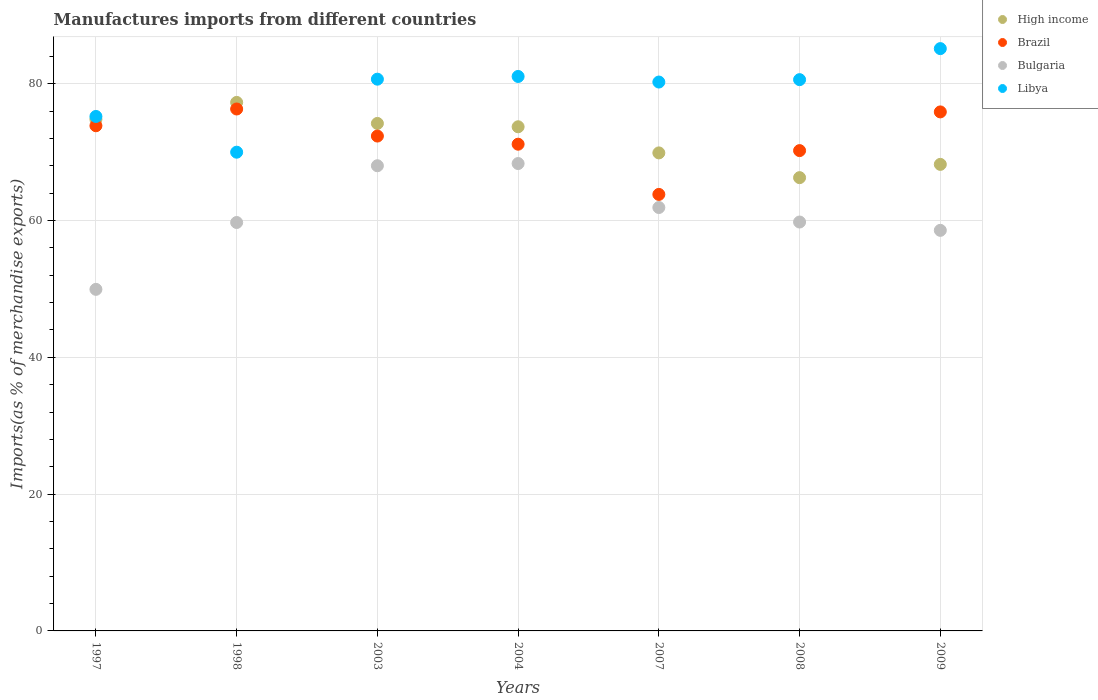Is the number of dotlines equal to the number of legend labels?
Offer a very short reply. Yes. What is the percentage of imports to different countries in Libya in 2004?
Give a very brief answer. 81.06. Across all years, what is the maximum percentage of imports to different countries in Libya?
Offer a terse response. 85.13. Across all years, what is the minimum percentage of imports to different countries in Libya?
Your answer should be compact. 69.99. What is the total percentage of imports to different countries in High income in the graph?
Your answer should be very brief. 504.31. What is the difference between the percentage of imports to different countries in Libya in 2004 and that in 2007?
Your response must be concise. 0.82. What is the difference between the percentage of imports to different countries in Brazil in 2003 and the percentage of imports to different countries in Bulgaria in 2008?
Offer a terse response. 12.57. What is the average percentage of imports to different countries in Libya per year?
Provide a succinct answer. 78.98. In the year 2004, what is the difference between the percentage of imports to different countries in Bulgaria and percentage of imports to different countries in Brazil?
Offer a terse response. -2.83. What is the ratio of the percentage of imports to different countries in Brazil in 1997 to that in 2007?
Ensure brevity in your answer.  1.16. What is the difference between the highest and the second highest percentage of imports to different countries in Libya?
Your response must be concise. 4.07. What is the difference between the highest and the lowest percentage of imports to different countries in Brazil?
Offer a terse response. 12.49. Is the sum of the percentage of imports to different countries in Bulgaria in 2003 and 2004 greater than the maximum percentage of imports to different countries in Brazil across all years?
Provide a succinct answer. Yes. Does the percentage of imports to different countries in Brazil monotonically increase over the years?
Your answer should be very brief. No. Is the percentage of imports to different countries in Bulgaria strictly greater than the percentage of imports to different countries in High income over the years?
Provide a succinct answer. No. How many dotlines are there?
Give a very brief answer. 4. What is the difference between two consecutive major ticks on the Y-axis?
Give a very brief answer. 20. Does the graph contain any zero values?
Ensure brevity in your answer.  No. Does the graph contain grids?
Offer a very short reply. Yes. What is the title of the graph?
Keep it short and to the point. Manufactures imports from different countries. Does "Pacific island small states" appear as one of the legend labels in the graph?
Your response must be concise. No. What is the label or title of the X-axis?
Give a very brief answer. Years. What is the label or title of the Y-axis?
Ensure brevity in your answer.  Imports(as % of merchandise exports). What is the Imports(as % of merchandise exports) of High income in 1997?
Your response must be concise. 74.79. What is the Imports(as % of merchandise exports) in Brazil in 1997?
Your response must be concise. 73.85. What is the Imports(as % of merchandise exports) of Bulgaria in 1997?
Offer a very short reply. 49.93. What is the Imports(as % of merchandise exports) of Libya in 1997?
Offer a terse response. 75.21. What is the Imports(as % of merchandise exports) of High income in 1998?
Your answer should be compact. 77.27. What is the Imports(as % of merchandise exports) in Brazil in 1998?
Make the answer very short. 76.3. What is the Imports(as % of merchandise exports) in Bulgaria in 1998?
Provide a short and direct response. 59.71. What is the Imports(as % of merchandise exports) in Libya in 1998?
Your answer should be compact. 69.99. What is the Imports(as % of merchandise exports) of High income in 2003?
Ensure brevity in your answer.  74.19. What is the Imports(as % of merchandise exports) of Brazil in 2003?
Your answer should be compact. 72.35. What is the Imports(as % of merchandise exports) in Bulgaria in 2003?
Give a very brief answer. 68.01. What is the Imports(as % of merchandise exports) in Libya in 2003?
Give a very brief answer. 80.66. What is the Imports(as % of merchandise exports) in High income in 2004?
Provide a succinct answer. 73.7. What is the Imports(as % of merchandise exports) in Brazil in 2004?
Provide a short and direct response. 71.16. What is the Imports(as % of merchandise exports) in Bulgaria in 2004?
Keep it short and to the point. 68.33. What is the Imports(as % of merchandise exports) in Libya in 2004?
Make the answer very short. 81.06. What is the Imports(as % of merchandise exports) in High income in 2007?
Give a very brief answer. 69.88. What is the Imports(as % of merchandise exports) of Brazil in 2007?
Your answer should be compact. 63.82. What is the Imports(as % of merchandise exports) in Bulgaria in 2007?
Offer a very short reply. 61.9. What is the Imports(as % of merchandise exports) of Libya in 2007?
Your answer should be very brief. 80.24. What is the Imports(as % of merchandise exports) in High income in 2008?
Provide a short and direct response. 66.27. What is the Imports(as % of merchandise exports) of Brazil in 2008?
Your answer should be very brief. 70.22. What is the Imports(as % of merchandise exports) of Bulgaria in 2008?
Provide a succinct answer. 59.78. What is the Imports(as % of merchandise exports) of Libya in 2008?
Your response must be concise. 80.59. What is the Imports(as % of merchandise exports) in High income in 2009?
Keep it short and to the point. 68.21. What is the Imports(as % of merchandise exports) of Brazil in 2009?
Give a very brief answer. 75.88. What is the Imports(as % of merchandise exports) of Bulgaria in 2009?
Provide a succinct answer. 58.56. What is the Imports(as % of merchandise exports) of Libya in 2009?
Ensure brevity in your answer.  85.13. Across all years, what is the maximum Imports(as % of merchandise exports) in High income?
Keep it short and to the point. 77.27. Across all years, what is the maximum Imports(as % of merchandise exports) in Brazil?
Provide a short and direct response. 76.3. Across all years, what is the maximum Imports(as % of merchandise exports) in Bulgaria?
Provide a succinct answer. 68.33. Across all years, what is the maximum Imports(as % of merchandise exports) in Libya?
Make the answer very short. 85.13. Across all years, what is the minimum Imports(as % of merchandise exports) of High income?
Your answer should be very brief. 66.27. Across all years, what is the minimum Imports(as % of merchandise exports) of Brazil?
Offer a very short reply. 63.82. Across all years, what is the minimum Imports(as % of merchandise exports) in Bulgaria?
Give a very brief answer. 49.93. Across all years, what is the minimum Imports(as % of merchandise exports) of Libya?
Make the answer very short. 69.99. What is the total Imports(as % of merchandise exports) in High income in the graph?
Offer a terse response. 504.31. What is the total Imports(as % of merchandise exports) in Brazil in the graph?
Offer a terse response. 503.57. What is the total Imports(as % of merchandise exports) in Bulgaria in the graph?
Make the answer very short. 426.22. What is the total Imports(as % of merchandise exports) of Libya in the graph?
Provide a succinct answer. 552.89. What is the difference between the Imports(as % of merchandise exports) of High income in 1997 and that in 1998?
Make the answer very short. -2.48. What is the difference between the Imports(as % of merchandise exports) of Brazil in 1997 and that in 1998?
Keep it short and to the point. -2.45. What is the difference between the Imports(as % of merchandise exports) in Bulgaria in 1997 and that in 1998?
Provide a short and direct response. -9.77. What is the difference between the Imports(as % of merchandise exports) of Libya in 1997 and that in 1998?
Your response must be concise. 5.23. What is the difference between the Imports(as % of merchandise exports) of High income in 1997 and that in 2003?
Provide a short and direct response. 0.6. What is the difference between the Imports(as % of merchandise exports) of Brazil in 1997 and that in 2003?
Provide a succinct answer. 1.51. What is the difference between the Imports(as % of merchandise exports) of Bulgaria in 1997 and that in 2003?
Keep it short and to the point. -18.07. What is the difference between the Imports(as % of merchandise exports) of Libya in 1997 and that in 2003?
Provide a succinct answer. -5.45. What is the difference between the Imports(as % of merchandise exports) of High income in 1997 and that in 2004?
Make the answer very short. 1.08. What is the difference between the Imports(as % of merchandise exports) of Brazil in 1997 and that in 2004?
Make the answer very short. 2.7. What is the difference between the Imports(as % of merchandise exports) in Bulgaria in 1997 and that in 2004?
Keep it short and to the point. -18.39. What is the difference between the Imports(as % of merchandise exports) of Libya in 1997 and that in 2004?
Your answer should be very brief. -5.85. What is the difference between the Imports(as % of merchandise exports) in High income in 1997 and that in 2007?
Ensure brevity in your answer.  4.9. What is the difference between the Imports(as % of merchandise exports) in Brazil in 1997 and that in 2007?
Your answer should be very brief. 10.04. What is the difference between the Imports(as % of merchandise exports) in Bulgaria in 1997 and that in 2007?
Make the answer very short. -11.97. What is the difference between the Imports(as % of merchandise exports) in Libya in 1997 and that in 2007?
Your answer should be compact. -5.03. What is the difference between the Imports(as % of merchandise exports) in High income in 1997 and that in 2008?
Provide a succinct answer. 8.52. What is the difference between the Imports(as % of merchandise exports) of Brazil in 1997 and that in 2008?
Provide a succinct answer. 3.63. What is the difference between the Imports(as % of merchandise exports) in Bulgaria in 1997 and that in 2008?
Ensure brevity in your answer.  -9.84. What is the difference between the Imports(as % of merchandise exports) of Libya in 1997 and that in 2008?
Your response must be concise. -5.38. What is the difference between the Imports(as % of merchandise exports) of High income in 1997 and that in 2009?
Offer a terse response. 6.58. What is the difference between the Imports(as % of merchandise exports) of Brazil in 1997 and that in 2009?
Provide a succinct answer. -2.02. What is the difference between the Imports(as % of merchandise exports) in Bulgaria in 1997 and that in 2009?
Give a very brief answer. -8.63. What is the difference between the Imports(as % of merchandise exports) of Libya in 1997 and that in 2009?
Offer a terse response. -9.92. What is the difference between the Imports(as % of merchandise exports) in High income in 1998 and that in 2003?
Offer a terse response. 3.07. What is the difference between the Imports(as % of merchandise exports) of Brazil in 1998 and that in 2003?
Offer a very short reply. 3.96. What is the difference between the Imports(as % of merchandise exports) in Bulgaria in 1998 and that in 2003?
Offer a terse response. -8.3. What is the difference between the Imports(as % of merchandise exports) in Libya in 1998 and that in 2003?
Ensure brevity in your answer.  -10.68. What is the difference between the Imports(as % of merchandise exports) in High income in 1998 and that in 2004?
Your response must be concise. 3.56. What is the difference between the Imports(as % of merchandise exports) of Brazil in 1998 and that in 2004?
Make the answer very short. 5.15. What is the difference between the Imports(as % of merchandise exports) in Bulgaria in 1998 and that in 2004?
Give a very brief answer. -8.62. What is the difference between the Imports(as % of merchandise exports) of Libya in 1998 and that in 2004?
Provide a succinct answer. -11.07. What is the difference between the Imports(as % of merchandise exports) of High income in 1998 and that in 2007?
Give a very brief answer. 7.38. What is the difference between the Imports(as % of merchandise exports) of Brazil in 1998 and that in 2007?
Offer a very short reply. 12.49. What is the difference between the Imports(as % of merchandise exports) of Bulgaria in 1998 and that in 2007?
Your response must be concise. -2.19. What is the difference between the Imports(as % of merchandise exports) of Libya in 1998 and that in 2007?
Provide a succinct answer. -10.26. What is the difference between the Imports(as % of merchandise exports) of High income in 1998 and that in 2008?
Keep it short and to the point. 11. What is the difference between the Imports(as % of merchandise exports) in Brazil in 1998 and that in 2008?
Give a very brief answer. 6.08. What is the difference between the Imports(as % of merchandise exports) of Bulgaria in 1998 and that in 2008?
Make the answer very short. -0.07. What is the difference between the Imports(as % of merchandise exports) in Libya in 1998 and that in 2008?
Offer a terse response. -10.61. What is the difference between the Imports(as % of merchandise exports) in High income in 1998 and that in 2009?
Provide a succinct answer. 9.06. What is the difference between the Imports(as % of merchandise exports) of Brazil in 1998 and that in 2009?
Give a very brief answer. 0.43. What is the difference between the Imports(as % of merchandise exports) of Bulgaria in 1998 and that in 2009?
Offer a very short reply. 1.15. What is the difference between the Imports(as % of merchandise exports) in Libya in 1998 and that in 2009?
Provide a short and direct response. -15.14. What is the difference between the Imports(as % of merchandise exports) in High income in 2003 and that in 2004?
Make the answer very short. 0.49. What is the difference between the Imports(as % of merchandise exports) in Brazil in 2003 and that in 2004?
Ensure brevity in your answer.  1.19. What is the difference between the Imports(as % of merchandise exports) in Bulgaria in 2003 and that in 2004?
Keep it short and to the point. -0.32. What is the difference between the Imports(as % of merchandise exports) of Libya in 2003 and that in 2004?
Make the answer very short. -0.4. What is the difference between the Imports(as % of merchandise exports) of High income in 2003 and that in 2007?
Make the answer very short. 4.31. What is the difference between the Imports(as % of merchandise exports) of Brazil in 2003 and that in 2007?
Offer a terse response. 8.53. What is the difference between the Imports(as % of merchandise exports) in Bulgaria in 2003 and that in 2007?
Provide a succinct answer. 6.11. What is the difference between the Imports(as % of merchandise exports) of Libya in 2003 and that in 2007?
Provide a succinct answer. 0.42. What is the difference between the Imports(as % of merchandise exports) of High income in 2003 and that in 2008?
Ensure brevity in your answer.  7.93. What is the difference between the Imports(as % of merchandise exports) of Brazil in 2003 and that in 2008?
Ensure brevity in your answer.  2.13. What is the difference between the Imports(as % of merchandise exports) of Bulgaria in 2003 and that in 2008?
Give a very brief answer. 8.23. What is the difference between the Imports(as % of merchandise exports) in Libya in 2003 and that in 2008?
Ensure brevity in your answer.  0.07. What is the difference between the Imports(as % of merchandise exports) of High income in 2003 and that in 2009?
Your answer should be very brief. 5.98. What is the difference between the Imports(as % of merchandise exports) in Brazil in 2003 and that in 2009?
Keep it short and to the point. -3.53. What is the difference between the Imports(as % of merchandise exports) of Bulgaria in 2003 and that in 2009?
Your answer should be very brief. 9.45. What is the difference between the Imports(as % of merchandise exports) in Libya in 2003 and that in 2009?
Offer a terse response. -4.47. What is the difference between the Imports(as % of merchandise exports) in High income in 2004 and that in 2007?
Offer a very short reply. 3.82. What is the difference between the Imports(as % of merchandise exports) in Brazil in 2004 and that in 2007?
Offer a terse response. 7.34. What is the difference between the Imports(as % of merchandise exports) of Bulgaria in 2004 and that in 2007?
Offer a very short reply. 6.43. What is the difference between the Imports(as % of merchandise exports) in Libya in 2004 and that in 2007?
Your answer should be very brief. 0.82. What is the difference between the Imports(as % of merchandise exports) of High income in 2004 and that in 2008?
Your answer should be compact. 7.44. What is the difference between the Imports(as % of merchandise exports) in Brazil in 2004 and that in 2008?
Keep it short and to the point. 0.94. What is the difference between the Imports(as % of merchandise exports) of Bulgaria in 2004 and that in 2008?
Provide a succinct answer. 8.55. What is the difference between the Imports(as % of merchandise exports) of Libya in 2004 and that in 2008?
Provide a succinct answer. 0.47. What is the difference between the Imports(as % of merchandise exports) in High income in 2004 and that in 2009?
Offer a very short reply. 5.5. What is the difference between the Imports(as % of merchandise exports) of Brazil in 2004 and that in 2009?
Your answer should be very brief. -4.72. What is the difference between the Imports(as % of merchandise exports) in Bulgaria in 2004 and that in 2009?
Provide a succinct answer. 9.77. What is the difference between the Imports(as % of merchandise exports) of Libya in 2004 and that in 2009?
Give a very brief answer. -4.07. What is the difference between the Imports(as % of merchandise exports) in High income in 2007 and that in 2008?
Offer a terse response. 3.62. What is the difference between the Imports(as % of merchandise exports) in Brazil in 2007 and that in 2008?
Ensure brevity in your answer.  -6.4. What is the difference between the Imports(as % of merchandise exports) in Bulgaria in 2007 and that in 2008?
Provide a succinct answer. 2.12. What is the difference between the Imports(as % of merchandise exports) of Libya in 2007 and that in 2008?
Your response must be concise. -0.35. What is the difference between the Imports(as % of merchandise exports) in High income in 2007 and that in 2009?
Keep it short and to the point. 1.68. What is the difference between the Imports(as % of merchandise exports) in Brazil in 2007 and that in 2009?
Keep it short and to the point. -12.06. What is the difference between the Imports(as % of merchandise exports) in Bulgaria in 2007 and that in 2009?
Provide a short and direct response. 3.34. What is the difference between the Imports(as % of merchandise exports) in Libya in 2007 and that in 2009?
Offer a very short reply. -4.89. What is the difference between the Imports(as % of merchandise exports) of High income in 2008 and that in 2009?
Offer a terse response. -1.94. What is the difference between the Imports(as % of merchandise exports) of Brazil in 2008 and that in 2009?
Your answer should be compact. -5.66. What is the difference between the Imports(as % of merchandise exports) of Bulgaria in 2008 and that in 2009?
Your answer should be very brief. 1.22. What is the difference between the Imports(as % of merchandise exports) of Libya in 2008 and that in 2009?
Keep it short and to the point. -4.54. What is the difference between the Imports(as % of merchandise exports) of High income in 1997 and the Imports(as % of merchandise exports) of Brazil in 1998?
Provide a short and direct response. -1.52. What is the difference between the Imports(as % of merchandise exports) of High income in 1997 and the Imports(as % of merchandise exports) of Bulgaria in 1998?
Ensure brevity in your answer.  15.08. What is the difference between the Imports(as % of merchandise exports) in High income in 1997 and the Imports(as % of merchandise exports) in Libya in 1998?
Ensure brevity in your answer.  4.8. What is the difference between the Imports(as % of merchandise exports) of Brazil in 1997 and the Imports(as % of merchandise exports) of Bulgaria in 1998?
Your answer should be compact. 14.14. What is the difference between the Imports(as % of merchandise exports) in Brazil in 1997 and the Imports(as % of merchandise exports) in Libya in 1998?
Provide a short and direct response. 3.87. What is the difference between the Imports(as % of merchandise exports) of Bulgaria in 1997 and the Imports(as % of merchandise exports) of Libya in 1998?
Your answer should be very brief. -20.05. What is the difference between the Imports(as % of merchandise exports) in High income in 1997 and the Imports(as % of merchandise exports) in Brazil in 2003?
Offer a terse response. 2.44. What is the difference between the Imports(as % of merchandise exports) in High income in 1997 and the Imports(as % of merchandise exports) in Bulgaria in 2003?
Your response must be concise. 6.78. What is the difference between the Imports(as % of merchandise exports) of High income in 1997 and the Imports(as % of merchandise exports) of Libya in 2003?
Provide a short and direct response. -5.87. What is the difference between the Imports(as % of merchandise exports) of Brazil in 1997 and the Imports(as % of merchandise exports) of Bulgaria in 2003?
Provide a succinct answer. 5.85. What is the difference between the Imports(as % of merchandise exports) of Brazil in 1997 and the Imports(as % of merchandise exports) of Libya in 2003?
Your response must be concise. -6.81. What is the difference between the Imports(as % of merchandise exports) in Bulgaria in 1997 and the Imports(as % of merchandise exports) in Libya in 2003?
Provide a short and direct response. -30.73. What is the difference between the Imports(as % of merchandise exports) of High income in 1997 and the Imports(as % of merchandise exports) of Brazil in 2004?
Ensure brevity in your answer.  3.63. What is the difference between the Imports(as % of merchandise exports) in High income in 1997 and the Imports(as % of merchandise exports) in Bulgaria in 2004?
Your answer should be compact. 6.46. What is the difference between the Imports(as % of merchandise exports) of High income in 1997 and the Imports(as % of merchandise exports) of Libya in 2004?
Provide a short and direct response. -6.27. What is the difference between the Imports(as % of merchandise exports) of Brazil in 1997 and the Imports(as % of merchandise exports) of Bulgaria in 2004?
Your answer should be compact. 5.52. What is the difference between the Imports(as % of merchandise exports) of Brazil in 1997 and the Imports(as % of merchandise exports) of Libya in 2004?
Make the answer very short. -7.21. What is the difference between the Imports(as % of merchandise exports) in Bulgaria in 1997 and the Imports(as % of merchandise exports) in Libya in 2004?
Keep it short and to the point. -31.12. What is the difference between the Imports(as % of merchandise exports) of High income in 1997 and the Imports(as % of merchandise exports) of Brazil in 2007?
Your answer should be compact. 10.97. What is the difference between the Imports(as % of merchandise exports) in High income in 1997 and the Imports(as % of merchandise exports) in Bulgaria in 2007?
Give a very brief answer. 12.89. What is the difference between the Imports(as % of merchandise exports) of High income in 1997 and the Imports(as % of merchandise exports) of Libya in 2007?
Offer a terse response. -5.46. What is the difference between the Imports(as % of merchandise exports) in Brazil in 1997 and the Imports(as % of merchandise exports) in Bulgaria in 2007?
Keep it short and to the point. 11.95. What is the difference between the Imports(as % of merchandise exports) of Brazil in 1997 and the Imports(as % of merchandise exports) of Libya in 2007?
Provide a short and direct response. -6.39. What is the difference between the Imports(as % of merchandise exports) in Bulgaria in 1997 and the Imports(as % of merchandise exports) in Libya in 2007?
Offer a very short reply. -30.31. What is the difference between the Imports(as % of merchandise exports) in High income in 1997 and the Imports(as % of merchandise exports) in Brazil in 2008?
Ensure brevity in your answer.  4.57. What is the difference between the Imports(as % of merchandise exports) of High income in 1997 and the Imports(as % of merchandise exports) of Bulgaria in 2008?
Your answer should be very brief. 15.01. What is the difference between the Imports(as % of merchandise exports) of High income in 1997 and the Imports(as % of merchandise exports) of Libya in 2008?
Offer a very short reply. -5.81. What is the difference between the Imports(as % of merchandise exports) in Brazil in 1997 and the Imports(as % of merchandise exports) in Bulgaria in 2008?
Your response must be concise. 14.07. What is the difference between the Imports(as % of merchandise exports) in Brazil in 1997 and the Imports(as % of merchandise exports) in Libya in 2008?
Make the answer very short. -6.74. What is the difference between the Imports(as % of merchandise exports) in Bulgaria in 1997 and the Imports(as % of merchandise exports) in Libya in 2008?
Give a very brief answer. -30.66. What is the difference between the Imports(as % of merchandise exports) of High income in 1997 and the Imports(as % of merchandise exports) of Brazil in 2009?
Give a very brief answer. -1.09. What is the difference between the Imports(as % of merchandise exports) of High income in 1997 and the Imports(as % of merchandise exports) of Bulgaria in 2009?
Your answer should be very brief. 16.23. What is the difference between the Imports(as % of merchandise exports) in High income in 1997 and the Imports(as % of merchandise exports) in Libya in 2009?
Provide a succinct answer. -10.34. What is the difference between the Imports(as % of merchandise exports) of Brazil in 1997 and the Imports(as % of merchandise exports) of Bulgaria in 2009?
Make the answer very short. 15.29. What is the difference between the Imports(as % of merchandise exports) of Brazil in 1997 and the Imports(as % of merchandise exports) of Libya in 2009?
Provide a succinct answer. -11.28. What is the difference between the Imports(as % of merchandise exports) in Bulgaria in 1997 and the Imports(as % of merchandise exports) in Libya in 2009?
Your answer should be compact. -35.2. What is the difference between the Imports(as % of merchandise exports) in High income in 1998 and the Imports(as % of merchandise exports) in Brazil in 2003?
Your response must be concise. 4.92. What is the difference between the Imports(as % of merchandise exports) in High income in 1998 and the Imports(as % of merchandise exports) in Bulgaria in 2003?
Offer a very short reply. 9.26. What is the difference between the Imports(as % of merchandise exports) in High income in 1998 and the Imports(as % of merchandise exports) in Libya in 2003?
Your response must be concise. -3.4. What is the difference between the Imports(as % of merchandise exports) of Brazil in 1998 and the Imports(as % of merchandise exports) of Bulgaria in 2003?
Offer a terse response. 8.3. What is the difference between the Imports(as % of merchandise exports) in Brazil in 1998 and the Imports(as % of merchandise exports) in Libya in 2003?
Give a very brief answer. -4.36. What is the difference between the Imports(as % of merchandise exports) of Bulgaria in 1998 and the Imports(as % of merchandise exports) of Libya in 2003?
Keep it short and to the point. -20.95. What is the difference between the Imports(as % of merchandise exports) of High income in 1998 and the Imports(as % of merchandise exports) of Brazil in 2004?
Give a very brief answer. 6.11. What is the difference between the Imports(as % of merchandise exports) in High income in 1998 and the Imports(as % of merchandise exports) in Bulgaria in 2004?
Make the answer very short. 8.94. What is the difference between the Imports(as % of merchandise exports) of High income in 1998 and the Imports(as % of merchandise exports) of Libya in 2004?
Provide a short and direct response. -3.79. What is the difference between the Imports(as % of merchandise exports) of Brazil in 1998 and the Imports(as % of merchandise exports) of Bulgaria in 2004?
Provide a short and direct response. 7.97. What is the difference between the Imports(as % of merchandise exports) of Brazil in 1998 and the Imports(as % of merchandise exports) of Libya in 2004?
Provide a succinct answer. -4.76. What is the difference between the Imports(as % of merchandise exports) of Bulgaria in 1998 and the Imports(as % of merchandise exports) of Libya in 2004?
Provide a succinct answer. -21.35. What is the difference between the Imports(as % of merchandise exports) in High income in 1998 and the Imports(as % of merchandise exports) in Brazil in 2007?
Your answer should be very brief. 13.45. What is the difference between the Imports(as % of merchandise exports) in High income in 1998 and the Imports(as % of merchandise exports) in Bulgaria in 2007?
Your answer should be very brief. 15.37. What is the difference between the Imports(as % of merchandise exports) in High income in 1998 and the Imports(as % of merchandise exports) in Libya in 2007?
Your response must be concise. -2.98. What is the difference between the Imports(as % of merchandise exports) in Brazil in 1998 and the Imports(as % of merchandise exports) in Bulgaria in 2007?
Your answer should be very brief. 14.4. What is the difference between the Imports(as % of merchandise exports) in Brazil in 1998 and the Imports(as % of merchandise exports) in Libya in 2007?
Your response must be concise. -3.94. What is the difference between the Imports(as % of merchandise exports) of Bulgaria in 1998 and the Imports(as % of merchandise exports) of Libya in 2007?
Your answer should be very brief. -20.53. What is the difference between the Imports(as % of merchandise exports) of High income in 1998 and the Imports(as % of merchandise exports) of Brazil in 2008?
Your answer should be compact. 7.05. What is the difference between the Imports(as % of merchandise exports) of High income in 1998 and the Imports(as % of merchandise exports) of Bulgaria in 2008?
Offer a very short reply. 17.49. What is the difference between the Imports(as % of merchandise exports) in High income in 1998 and the Imports(as % of merchandise exports) in Libya in 2008?
Make the answer very short. -3.33. What is the difference between the Imports(as % of merchandise exports) in Brazil in 1998 and the Imports(as % of merchandise exports) in Bulgaria in 2008?
Ensure brevity in your answer.  16.52. What is the difference between the Imports(as % of merchandise exports) in Brazil in 1998 and the Imports(as % of merchandise exports) in Libya in 2008?
Make the answer very short. -4.29. What is the difference between the Imports(as % of merchandise exports) in Bulgaria in 1998 and the Imports(as % of merchandise exports) in Libya in 2008?
Give a very brief answer. -20.88. What is the difference between the Imports(as % of merchandise exports) of High income in 1998 and the Imports(as % of merchandise exports) of Brazil in 2009?
Your answer should be very brief. 1.39. What is the difference between the Imports(as % of merchandise exports) of High income in 1998 and the Imports(as % of merchandise exports) of Bulgaria in 2009?
Provide a short and direct response. 18.7. What is the difference between the Imports(as % of merchandise exports) of High income in 1998 and the Imports(as % of merchandise exports) of Libya in 2009?
Keep it short and to the point. -7.87. What is the difference between the Imports(as % of merchandise exports) of Brazil in 1998 and the Imports(as % of merchandise exports) of Bulgaria in 2009?
Offer a terse response. 17.74. What is the difference between the Imports(as % of merchandise exports) in Brazil in 1998 and the Imports(as % of merchandise exports) in Libya in 2009?
Offer a very short reply. -8.83. What is the difference between the Imports(as % of merchandise exports) in Bulgaria in 1998 and the Imports(as % of merchandise exports) in Libya in 2009?
Your response must be concise. -25.42. What is the difference between the Imports(as % of merchandise exports) in High income in 2003 and the Imports(as % of merchandise exports) in Brazil in 2004?
Provide a short and direct response. 3.04. What is the difference between the Imports(as % of merchandise exports) of High income in 2003 and the Imports(as % of merchandise exports) of Bulgaria in 2004?
Your answer should be very brief. 5.86. What is the difference between the Imports(as % of merchandise exports) in High income in 2003 and the Imports(as % of merchandise exports) in Libya in 2004?
Provide a succinct answer. -6.87. What is the difference between the Imports(as % of merchandise exports) in Brazil in 2003 and the Imports(as % of merchandise exports) in Bulgaria in 2004?
Make the answer very short. 4.02. What is the difference between the Imports(as % of merchandise exports) of Brazil in 2003 and the Imports(as % of merchandise exports) of Libya in 2004?
Provide a short and direct response. -8.71. What is the difference between the Imports(as % of merchandise exports) in Bulgaria in 2003 and the Imports(as % of merchandise exports) in Libya in 2004?
Make the answer very short. -13.05. What is the difference between the Imports(as % of merchandise exports) in High income in 2003 and the Imports(as % of merchandise exports) in Brazil in 2007?
Give a very brief answer. 10.38. What is the difference between the Imports(as % of merchandise exports) of High income in 2003 and the Imports(as % of merchandise exports) of Bulgaria in 2007?
Provide a short and direct response. 12.29. What is the difference between the Imports(as % of merchandise exports) in High income in 2003 and the Imports(as % of merchandise exports) in Libya in 2007?
Provide a short and direct response. -6.05. What is the difference between the Imports(as % of merchandise exports) in Brazil in 2003 and the Imports(as % of merchandise exports) in Bulgaria in 2007?
Ensure brevity in your answer.  10.45. What is the difference between the Imports(as % of merchandise exports) in Brazil in 2003 and the Imports(as % of merchandise exports) in Libya in 2007?
Give a very brief answer. -7.9. What is the difference between the Imports(as % of merchandise exports) of Bulgaria in 2003 and the Imports(as % of merchandise exports) of Libya in 2007?
Provide a succinct answer. -12.24. What is the difference between the Imports(as % of merchandise exports) of High income in 2003 and the Imports(as % of merchandise exports) of Brazil in 2008?
Offer a very short reply. 3.97. What is the difference between the Imports(as % of merchandise exports) in High income in 2003 and the Imports(as % of merchandise exports) in Bulgaria in 2008?
Ensure brevity in your answer.  14.41. What is the difference between the Imports(as % of merchandise exports) in High income in 2003 and the Imports(as % of merchandise exports) in Libya in 2008?
Provide a short and direct response. -6.4. What is the difference between the Imports(as % of merchandise exports) of Brazil in 2003 and the Imports(as % of merchandise exports) of Bulgaria in 2008?
Give a very brief answer. 12.57. What is the difference between the Imports(as % of merchandise exports) of Brazil in 2003 and the Imports(as % of merchandise exports) of Libya in 2008?
Your answer should be compact. -8.25. What is the difference between the Imports(as % of merchandise exports) of Bulgaria in 2003 and the Imports(as % of merchandise exports) of Libya in 2008?
Make the answer very short. -12.59. What is the difference between the Imports(as % of merchandise exports) in High income in 2003 and the Imports(as % of merchandise exports) in Brazil in 2009?
Your response must be concise. -1.69. What is the difference between the Imports(as % of merchandise exports) in High income in 2003 and the Imports(as % of merchandise exports) in Bulgaria in 2009?
Your answer should be compact. 15.63. What is the difference between the Imports(as % of merchandise exports) in High income in 2003 and the Imports(as % of merchandise exports) in Libya in 2009?
Make the answer very short. -10.94. What is the difference between the Imports(as % of merchandise exports) in Brazil in 2003 and the Imports(as % of merchandise exports) in Bulgaria in 2009?
Provide a short and direct response. 13.78. What is the difference between the Imports(as % of merchandise exports) of Brazil in 2003 and the Imports(as % of merchandise exports) of Libya in 2009?
Provide a short and direct response. -12.78. What is the difference between the Imports(as % of merchandise exports) of Bulgaria in 2003 and the Imports(as % of merchandise exports) of Libya in 2009?
Your answer should be compact. -17.12. What is the difference between the Imports(as % of merchandise exports) of High income in 2004 and the Imports(as % of merchandise exports) of Brazil in 2007?
Make the answer very short. 9.89. What is the difference between the Imports(as % of merchandise exports) in High income in 2004 and the Imports(as % of merchandise exports) in Bulgaria in 2007?
Your answer should be compact. 11.8. What is the difference between the Imports(as % of merchandise exports) in High income in 2004 and the Imports(as % of merchandise exports) in Libya in 2007?
Your answer should be very brief. -6.54. What is the difference between the Imports(as % of merchandise exports) in Brazil in 2004 and the Imports(as % of merchandise exports) in Bulgaria in 2007?
Your response must be concise. 9.26. What is the difference between the Imports(as % of merchandise exports) of Brazil in 2004 and the Imports(as % of merchandise exports) of Libya in 2007?
Offer a very short reply. -9.09. What is the difference between the Imports(as % of merchandise exports) in Bulgaria in 2004 and the Imports(as % of merchandise exports) in Libya in 2007?
Your response must be concise. -11.92. What is the difference between the Imports(as % of merchandise exports) of High income in 2004 and the Imports(as % of merchandise exports) of Brazil in 2008?
Make the answer very short. 3.48. What is the difference between the Imports(as % of merchandise exports) in High income in 2004 and the Imports(as % of merchandise exports) in Bulgaria in 2008?
Provide a succinct answer. 13.92. What is the difference between the Imports(as % of merchandise exports) in High income in 2004 and the Imports(as % of merchandise exports) in Libya in 2008?
Provide a short and direct response. -6.89. What is the difference between the Imports(as % of merchandise exports) in Brazil in 2004 and the Imports(as % of merchandise exports) in Bulgaria in 2008?
Provide a succinct answer. 11.38. What is the difference between the Imports(as % of merchandise exports) in Brazil in 2004 and the Imports(as % of merchandise exports) in Libya in 2008?
Your answer should be compact. -9.44. What is the difference between the Imports(as % of merchandise exports) in Bulgaria in 2004 and the Imports(as % of merchandise exports) in Libya in 2008?
Give a very brief answer. -12.26. What is the difference between the Imports(as % of merchandise exports) of High income in 2004 and the Imports(as % of merchandise exports) of Brazil in 2009?
Keep it short and to the point. -2.17. What is the difference between the Imports(as % of merchandise exports) in High income in 2004 and the Imports(as % of merchandise exports) in Bulgaria in 2009?
Offer a very short reply. 15.14. What is the difference between the Imports(as % of merchandise exports) of High income in 2004 and the Imports(as % of merchandise exports) of Libya in 2009?
Keep it short and to the point. -11.43. What is the difference between the Imports(as % of merchandise exports) in Brazil in 2004 and the Imports(as % of merchandise exports) in Bulgaria in 2009?
Provide a succinct answer. 12.6. What is the difference between the Imports(as % of merchandise exports) of Brazil in 2004 and the Imports(as % of merchandise exports) of Libya in 2009?
Offer a terse response. -13.97. What is the difference between the Imports(as % of merchandise exports) in Bulgaria in 2004 and the Imports(as % of merchandise exports) in Libya in 2009?
Give a very brief answer. -16.8. What is the difference between the Imports(as % of merchandise exports) of High income in 2007 and the Imports(as % of merchandise exports) of Brazil in 2008?
Ensure brevity in your answer.  -0.34. What is the difference between the Imports(as % of merchandise exports) in High income in 2007 and the Imports(as % of merchandise exports) in Bulgaria in 2008?
Keep it short and to the point. 10.11. What is the difference between the Imports(as % of merchandise exports) of High income in 2007 and the Imports(as % of merchandise exports) of Libya in 2008?
Ensure brevity in your answer.  -10.71. What is the difference between the Imports(as % of merchandise exports) of Brazil in 2007 and the Imports(as % of merchandise exports) of Bulgaria in 2008?
Your answer should be compact. 4.04. What is the difference between the Imports(as % of merchandise exports) in Brazil in 2007 and the Imports(as % of merchandise exports) in Libya in 2008?
Make the answer very short. -16.78. What is the difference between the Imports(as % of merchandise exports) of Bulgaria in 2007 and the Imports(as % of merchandise exports) of Libya in 2008?
Your answer should be very brief. -18.69. What is the difference between the Imports(as % of merchandise exports) of High income in 2007 and the Imports(as % of merchandise exports) of Brazil in 2009?
Give a very brief answer. -5.99. What is the difference between the Imports(as % of merchandise exports) in High income in 2007 and the Imports(as % of merchandise exports) in Bulgaria in 2009?
Offer a very short reply. 11.32. What is the difference between the Imports(as % of merchandise exports) in High income in 2007 and the Imports(as % of merchandise exports) in Libya in 2009?
Ensure brevity in your answer.  -15.25. What is the difference between the Imports(as % of merchandise exports) in Brazil in 2007 and the Imports(as % of merchandise exports) in Bulgaria in 2009?
Your response must be concise. 5.25. What is the difference between the Imports(as % of merchandise exports) in Brazil in 2007 and the Imports(as % of merchandise exports) in Libya in 2009?
Provide a short and direct response. -21.32. What is the difference between the Imports(as % of merchandise exports) of Bulgaria in 2007 and the Imports(as % of merchandise exports) of Libya in 2009?
Provide a short and direct response. -23.23. What is the difference between the Imports(as % of merchandise exports) in High income in 2008 and the Imports(as % of merchandise exports) in Brazil in 2009?
Offer a terse response. -9.61. What is the difference between the Imports(as % of merchandise exports) in High income in 2008 and the Imports(as % of merchandise exports) in Bulgaria in 2009?
Make the answer very short. 7.7. What is the difference between the Imports(as % of merchandise exports) of High income in 2008 and the Imports(as % of merchandise exports) of Libya in 2009?
Provide a succinct answer. -18.86. What is the difference between the Imports(as % of merchandise exports) in Brazil in 2008 and the Imports(as % of merchandise exports) in Bulgaria in 2009?
Provide a short and direct response. 11.66. What is the difference between the Imports(as % of merchandise exports) of Brazil in 2008 and the Imports(as % of merchandise exports) of Libya in 2009?
Make the answer very short. -14.91. What is the difference between the Imports(as % of merchandise exports) of Bulgaria in 2008 and the Imports(as % of merchandise exports) of Libya in 2009?
Ensure brevity in your answer.  -25.35. What is the average Imports(as % of merchandise exports) of High income per year?
Offer a terse response. 72.04. What is the average Imports(as % of merchandise exports) in Brazil per year?
Make the answer very short. 71.94. What is the average Imports(as % of merchandise exports) of Bulgaria per year?
Your answer should be compact. 60.89. What is the average Imports(as % of merchandise exports) in Libya per year?
Your answer should be very brief. 78.98. In the year 1997, what is the difference between the Imports(as % of merchandise exports) of High income and Imports(as % of merchandise exports) of Brazil?
Your answer should be very brief. 0.93. In the year 1997, what is the difference between the Imports(as % of merchandise exports) of High income and Imports(as % of merchandise exports) of Bulgaria?
Keep it short and to the point. 24.85. In the year 1997, what is the difference between the Imports(as % of merchandise exports) in High income and Imports(as % of merchandise exports) in Libya?
Make the answer very short. -0.42. In the year 1997, what is the difference between the Imports(as % of merchandise exports) of Brazil and Imports(as % of merchandise exports) of Bulgaria?
Your answer should be compact. 23.92. In the year 1997, what is the difference between the Imports(as % of merchandise exports) of Brazil and Imports(as % of merchandise exports) of Libya?
Make the answer very short. -1.36. In the year 1997, what is the difference between the Imports(as % of merchandise exports) of Bulgaria and Imports(as % of merchandise exports) of Libya?
Ensure brevity in your answer.  -25.28. In the year 1998, what is the difference between the Imports(as % of merchandise exports) of High income and Imports(as % of merchandise exports) of Brazil?
Keep it short and to the point. 0.96. In the year 1998, what is the difference between the Imports(as % of merchandise exports) in High income and Imports(as % of merchandise exports) in Bulgaria?
Make the answer very short. 17.56. In the year 1998, what is the difference between the Imports(as % of merchandise exports) of High income and Imports(as % of merchandise exports) of Libya?
Ensure brevity in your answer.  7.28. In the year 1998, what is the difference between the Imports(as % of merchandise exports) in Brazil and Imports(as % of merchandise exports) in Bulgaria?
Keep it short and to the point. 16.59. In the year 1998, what is the difference between the Imports(as % of merchandise exports) in Brazil and Imports(as % of merchandise exports) in Libya?
Provide a short and direct response. 6.32. In the year 1998, what is the difference between the Imports(as % of merchandise exports) in Bulgaria and Imports(as % of merchandise exports) in Libya?
Your answer should be very brief. -10.28. In the year 2003, what is the difference between the Imports(as % of merchandise exports) of High income and Imports(as % of merchandise exports) of Brazil?
Your response must be concise. 1.85. In the year 2003, what is the difference between the Imports(as % of merchandise exports) in High income and Imports(as % of merchandise exports) in Bulgaria?
Provide a succinct answer. 6.18. In the year 2003, what is the difference between the Imports(as % of merchandise exports) in High income and Imports(as % of merchandise exports) in Libya?
Your answer should be compact. -6.47. In the year 2003, what is the difference between the Imports(as % of merchandise exports) of Brazil and Imports(as % of merchandise exports) of Bulgaria?
Your answer should be compact. 4.34. In the year 2003, what is the difference between the Imports(as % of merchandise exports) in Brazil and Imports(as % of merchandise exports) in Libya?
Keep it short and to the point. -8.32. In the year 2003, what is the difference between the Imports(as % of merchandise exports) in Bulgaria and Imports(as % of merchandise exports) in Libya?
Offer a terse response. -12.66. In the year 2004, what is the difference between the Imports(as % of merchandise exports) in High income and Imports(as % of merchandise exports) in Brazil?
Keep it short and to the point. 2.55. In the year 2004, what is the difference between the Imports(as % of merchandise exports) in High income and Imports(as % of merchandise exports) in Bulgaria?
Offer a terse response. 5.38. In the year 2004, what is the difference between the Imports(as % of merchandise exports) of High income and Imports(as % of merchandise exports) of Libya?
Provide a succinct answer. -7.36. In the year 2004, what is the difference between the Imports(as % of merchandise exports) of Brazil and Imports(as % of merchandise exports) of Bulgaria?
Your response must be concise. 2.83. In the year 2004, what is the difference between the Imports(as % of merchandise exports) of Brazil and Imports(as % of merchandise exports) of Libya?
Provide a succinct answer. -9.9. In the year 2004, what is the difference between the Imports(as % of merchandise exports) in Bulgaria and Imports(as % of merchandise exports) in Libya?
Provide a short and direct response. -12.73. In the year 2007, what is the difference between the Imports(as % of merchandise exports) in High income and Imports(as % of merchandise exports) in Brazil?
Your response must be concise. 6.07. In the year 2007, what is the difference between the Imports(as % of merchandise exports) of High income and Imports(as % of merchandise exports) of Bulgaria?
Give a very brief answer. 7.98. In the year 2007, what is the difference between the Imports(as % of merchandise exports) of High income and Imports(as % of merchandise exports) of Libya?
Provide a succinct answer. -10.36. In the year 2007, what is the difference between the Imports(as % of merchandise exports) in Brazil and Imports(as % of merchandise exports) in Bulgaria?
Keep it short and to the point. 1.91. In the year 2007, what is the difference between the Imports(as % of merchandise exports) in Brazil and Imports(as % of merchandise exports) in Libya?
Keep it short and to the point. -16.43. In the year 2007, what is the difference between the Imports(as % of merchandise exports) in Bulgaria and Imports(as % of merchandise exports) in Libya?
Keep it short and to the point. -18.34. In the year 2008, what is the difference between the Imports(as % of merchandise exports) in High income and Imports(as % of merchandise exports) in Brazil?
Ensure brevity in your answer.  -3.95. In the year 2008, what is the difference between the Imports(as % of merchandise exports) in High income and Imports(as % of merchandise exports) in Bulgaria?
Provide a succinct answer. 6.49. In the year 2008, what is the difference between the Imports(as % of merchandise exports) of High income and Imports(as % of merchandise exports) of Libya?
Make the answer very short. -14.33. In the year 2008, what is the difference between the Imports(as % of merchandise exports) of Brazil and Imports(as % of merchandise exports) of Bulgaria?
Provide a short and direct response. 10.44. In the year 2008, what is the difference between the Imports(as % of merchandise exports) in Brazil and Imports(as % of merchandise exports) in Libya?
Offer a terse response. -10.37. In the year 2008, what is the difference between the Imports(as % of merchandise exports) of Bulgaria and Imports(as % of merchandise exports) of Libya?
Give a very brief answer. -20.81. In the year 2009, what is the difference between the Imports(as % of merchandise exports) of High income and Imports(as % of merchandise exports) of Brazil?
Provide a succinct answer. -7.67. In the year 2009, what is the difference between the Imports(as % of merchandise exports) of High income and Imports(as % of merchandise exports) of Bulgaria?
Keep it short and to the point. 9.65. In the year 2009, what is the difference between the Imports(as % of merchandise exports) in High income and Imports(as % of merchandise exports) in Libya?
Make the answer very short. -16.92. In the year 2009, what is the difference between the Imports(as % of merchandise exports) of Brazil and Imports(as % of merchandise exports) of Bulgaria?
Ensure brevity in your answer.  17.32. In the year 2009, what is the difference between the Imports(as % of merchandise exports) in Brazil and Imports(as % of merchandise exports) in Libya?
Your answer should be compact. -9.25. In the year 2009, what is the difference between the Imports(as % of merchandise exports) of Bulgaria and Imports(as % of merchandise exports) of Libya?
Your answer should be very brief. -26.57. What is the ratio of the Imports(as % of merchandise exports) of High income in 1997 to that in 1998?
Keep it short and to the point. 0.97. What is the ratio of the Imports(as % of merchandise exports) in Brazil in 1997 to that in 1998?
Your answer should be very brief. 0.97. What is the ratio of the Imports(as % of merchandise exports) in Bulgaria in 1997 to that in 1998?
Provide a succinct answer. 0.84. What is the ratio of the Imports(as % of merchandise exports) in Libya in 1997 to that in 1998?
Make the answer very short. 1.07. What is the ratio of the Imports(as % of merchandise exports) of Brazil in 1997 to that in 2003?
Ensure brevity in your answer.  1.02. What is the ratio of the Imports(as % of merchandise exports) in Bulgaria in 1997 to that in 2003?
Your response must be concise. 0.73. What is the ratio of the Imports(as % of merchandise exports) in Libya in 1997 to that in 2003?
Offer a terse response. 0.93. What is the ratio of the Imports(as % of merchandise exports) in High income in 1997 to that in 2004?
Provide a succinct answer. 1.01. What is the ratio of the Imports(as % of merchandise exports) in Brazil in 1997 to that in 2004?
Give a very brief answer. 1.04. What is the ratio of the Imports(as % of merchandise exports) in Bulgaria in 1997 to that in 2004?
Offer a very short reply. 0.73. What is the ratio of the Imports(as % of merchandise exports) in Libya in 1997 to that in 2004?
Provide a short and direct response. 0.93. What is the ratio of the Imports(as % of merchandise exports) of High income in 1997 to that in 2007?
Keep it short and to the point. 1.07. What is the ratio of the Imports(as % of merchandise exports) in Brazil in 1997 to that in 2007?
Your response must be concise. 1.16. What is the ratio of the Imports(as % of merchandise exports) in Bulgaria in 1997 to that in 2007?
Keep it short and to the point. 0.81. What is the ratio of the Imports(as % of merchandise exports) in Libya in 1997 to that in 2007?
Keep it short and to the point. 0.94. What is the ratio of the Imports(as % of merchandise exports) in High income in 1997 to that in 2008?
Give a very brief answer. 1.13. What is the ratio of the Imports(as % of merchandise exports) in Brazil in 1997 to that in 2008?
Offer a very short reply. 1.05. What is the ratio of the Imports(as % of merchandise exports) of Bulgaria in 1997 to that in 2008?
Your answer should be compact. 0.84. What is the ratio of the Imports(as % of merchandise exports) in Libya in 1997 to that in 2008?
Offer a terse response. 0.93. What is the ratio of the Imports(as % of merchandise exports) of High income in 1997 to that in 2009?
Your answer should be very brief. 1.1. What is the ratio of the Imports(as % of merchandise exports) in Brazil in 1997 to that in 2009?
Offer a very short reply. 0.97. What is the ratio of the Imports(as % of merchandise exports) of Bulgaria in 1997 to that in 2009?
Ensure brevity in your answer.  0.85. What is the ratio of the Imports(as % of merchandise exports) in Libya in 1997 to that in 2009?
Your response must be concise. 0.88. What is the ratio of the Imports(as % of merchandise exports) in High income in 1998 to that in 2003?
Your answer should be very brief. 1.04. What is the ratio of the Imports(as % of merchandise exports) in Brazil in 1998 to that in 2003?
Keep it short and to the point. 1.05. What is the ratio of the Imports(as % of merchandise exports) of Bulgaria in 1998 to that in 2003?
Ensure brevity in your answer.  0.88. What is the ratio of the Imports(as % of merchandise exports) of Libya in 1998 to that in 2003?
Your answer should be compact. 0.87. What is the ratio of the Imports(as % of merchandise exports) in High income in 1998 to that in 2004?
Give a very brief answer. 1.05. What is the ratio of the Imports(as % of merchandise exports) in Brazil in 1998 to that in 2004?
Provide a short and direct response. 1.07. What is the ratio of the Imports(as % of merchandise exports) of Bulgaria in 1998 to that in 2004?
Provide a short and direct response. 0.87. What is the ratio of the Imports(as % of merchandise exports) in Libya in 1998 to that in 2004?
Provide a succinct answer. 0.86. What is the ratio of the Imports(as % of merchandise exports) in High income in 1998 to that in 2007?
Your response must be concise. 1.11. What is the ratio of the Imports(as % of merchandise exports) of Brazil in 1998 to that in 2007?
Your response must be concise. 1.2. What is the ratio of the Imports(as % of merchandise exports) of Bulgaria in 1998 to that in 2007?
Provide a succinct answer. 0.96. What is the ratio of the Imports(as % of merchandise exports) of Libya in 1998 to that in 2007?
Keep it short and to the point. 0.87. What is the ratio of the Imports(as % of merchandise exports) in High income in 1998 to that in 2008?
Your answer should be compact. 1.17. What is the ratio of the Imports(as % of merchandise exports) of Brazil in 1998 to that in 2008?
Your answer should be compact. 1.09. What is the ratio of the Imports(as % of merchandise exports) in Libya in 1998 to that in 2008?
Your response must be concise. 0.87. What is the ratio of the Imports(as % of merchandise exports) in High income in 1998 to that in 2009?
Your response must be concise. 1.13. What is the ratio of the Imports(as % of merchandise exports) of Brazil in 1998 to that in 2009?
Offer a terse response. 1.01. What is the ratio of the Imports(as % of merchandise exports) in Bulgaria in 1998 to that in 2009?
Offer a terse response. 1.02. What is the ratio of the Imports(as % of merchandise exports) of Libya in 1998 to that in 2009?
Provide a short and direct response. 0.82. What is the ratio of the Imports(as % of merchandise exports) of High income in 2003 to that in 2004?
Provide a succinct answer. 1.01. What is the ratio of the Imports(as % of merchandise exports) of Brazil in 2003 to that in 2004?
Your response must be concise. 1.02. What is the ratio of the Imports(as % of merchandise exports) of Bulgaria in 2003 to that in 2004?
Offer a very short reply. 1. What is the ratio of the Imports(as % of merchandise exports) of High income in 2003 to that in 2007?
Provide a succinct answer. 1.06. What is the ratio of the Imports(as % of merchandise exports) of Brazil in 2003 to that in 2007?
Keep it short and to the point. 1.13. What is the ratio of the Imports(as % of merchandise exports) of Bulgaria in 2003 to that in 2007?
Offer a terse response. 1.1. What is the ratio of the Imports(as % of merchandise exports) in Libya in 2003 to that in 2007?
Offer a very short reply. 1.01. What is the ratio of the Imports(as % of merchandise exports) in High income in 2003 to that in 2008?
Provide a short and direct response. 1.12. What is the ratio of the Imports(as % of merchandise exports) in Brazil in 2003 to that in 2008?
Ensure brevity in your answer.  1.03. What is the ratio of the Imports(as % of merchandise exports) in Bulgaria in 2003 to that in 2008?
Give a very brief answer. 1.14. What is the ratio of the Imports(as % of merchandise exports) in High income in 2003 to that in 2009?
Your answer should be very brief. 1.09. What is the ratio of the Imports(as % of merchandise exports) in Brazil in 2003 to that in 2009?
Offer a terse response. 0.95. What is the ratio of the Imports(as % of merchandise exports) in Bulgaria in 2003 to that in 2009?
Provide a succinct answer. 1.16. What is the ratio of the Imports(as % of merchandise exports) of Libya in 2003 to that in 2009?
Offer a terse response. 0.95. What is the ratio of the Imports(as % of merchandise exports) of High income in 2004 to that in 2007?
Your answer should be very brief. 1.05. What is the ratio of the Imports(as % of merchandise exports) in Brazil in 2004 to that in 2007?
Provide a short and direct response. 1.11. What is the ratio of the Imports(as % of merchandise exports) in Bulgaria in 2004 to that in 2007?
Ensure brevity in your answer.  1.1. What is the ratio of the Imports(as % of merchandise exports) of Libya in 2004 to that in 2007?
Offer a terse response. 1.01. What is the ratio of the Imports(as % of merchandise exports) of High income in 2004 to that in 2008?
Make the answer very short. 1.11. What is the ratio of the Imports(as % of merchandise exports) of Brazil in 2004 to that in 2008?
Provide a succinct answer. 1.01. What is the ratio of the Imports(as % of merchandise exports) of Bulgaria in 2004 to that in 2008?
Ensure brevity in your answer.  1.14. What is the ratio of the Imports(as % of merchandise exports) in Libya in 2004 to that in 2008?
Keep it short and to the point. 1.01. What is the ratio of the Imports(as % of merchandise exports) of High income in 2004 to that in 2009?
Offer a terse response. 1.08. What is the ratio of the Imports(as % of merchandise exports) of Brazil in 2004 to that in 2009?
Keep it short and to the point. 0.94. What is the ratio of the Imports(as % of merchandise exports) of Bulgaria in 2004 to that in 2009?
Your answer should be compact. 1.17. What is the ratio of the Imports(as % of merchandise exports) of Libya in 2004 to that in 2009?
Your answer should be compact. 0.95. What is the ratio of the Imports(as % of merchandise exports) in High income in 2007 to that in 2008?
Your answer should be compact. 1.05. What is the ratio of the Imports(as % of merchandise exports) in Brazil in 2007 to that in 2008?
Keep it short and to the point. 0.91. What is the ratio of the Imports(as % of merchandise exports) in Bulgaria in 2007 to that in 2008?
Offer a terse response. 1.04. What is the ratio of the Imports(as % of merchandise exports) of Libya in 2007 to that in 2008?
Offer a very short reply. 1. What is the ratio of the Imports(as % of merchandise exports) of High income in 2007 to that in 2009?
Ensure brevity in your answer.  1.02. What is the ratio of the Imports(as % of merchandise exports) of Brazil in 2007 to that in 2009?
Your answer should be compact. 0.84. What is the ratio of the Imports(as % of merchandise exports) in Bulgaria in 2007 to that in 2009?
Ensure brevity in your answer.  1.06. What is the ratio of the Imports(as % of merchandise exports) of Libya in 2007 to that in 2009?
Offer a very short reply. 0.94. What is the ratio of the Imports(as % of merchandise exports) of High income in 2008 to that in 2009?
Keep it short and to the point. 0.97. What is the ratio of the Imports(as % of merchandise exports) in Brazil in 2008 to that in 2009?
Your answer should be very brief. 0.93. What is the ratio of the Imports(as % of merchandise exports) of Bulgaria in 2008 to that in 2009?
Your answer should be very brief. 1.02. What is the ratio of the Imports(as % of merchandise exports) in Libya in 2008 to that in 2009?
Your answer should be very brief. 0.95. What is the difference between the highest and the second highest Imports(as % of merchandise exports) of High income?
Provide a short and direct response. 2.48. What is the difference between the highest and the second highest Imports(as % of merchandise exports) in Brazil?
Offer a terse response. 0.43. What is the difference between the highest and the second highest Imports(as % of merchandise exports) of Bulgaria?
Give a very brief answer. 0.32. What is the difference between the highest and the second highest Imports(as % of merchandise exports) of Libya?
Ensure brevity in your answer.  4.07. What is the difference between the highest and the lowest Imports(as % of merchandise exports) in High income?
Your response must be concise. 11. What is the difference between the highest and the lowest Imports(as % of merchandise exports) in Brazil?
Ensure brevity in your answer.  12.49. What is the difference between the highest and the lowest Imports(as % of merchandise exports) in Bulgaria?
Give a very brief answer. 18.39. What is the difference between the highest and the lowest Imports(as % of merchandise exports) of Libya?
Provide a short and direct response. 15.14. 